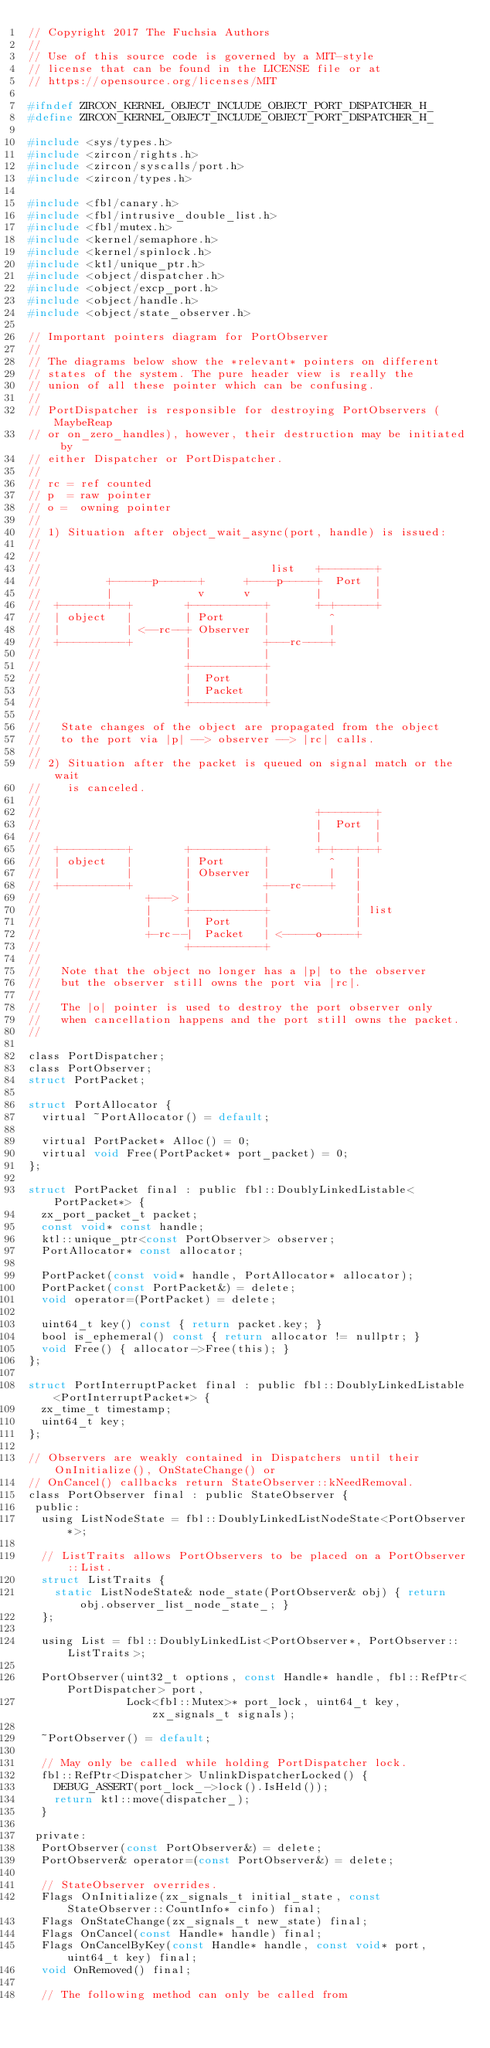Convert code to text. <code><loc_0><loc_0><loc_500><loc_500><_C_>// Copyright 2017 The Fuchsia Authors
//
// Use of this source code is governed by a MIT-style
// license that can be found in the LICENSE file or at
// https://opensource.org/licenses/MIT

#ifndef ZIRCON_KERNEL_OBJECT_INCLUDE_OBJECT_PORT_DISPATCHER_H_
#define ZIRCON_KERNEL_OBJECT_INCLUDE_OBJECT_PORT_DISPATCHER_H_

#include <sys/types.h>
#include <zircon/rights.h>
#include <zircon/syscalls/port.h>
#include <zircon/types.h>

#include <fbl/canary.h>
#include <fbl/intrusive_double_list.h>
#include <fbl/mutex.h>
#include <kernel/semaphore.h>
#include <kernel/spinlock.h>
#include <ktl/unique_ptr.h>
#include <object/dispatcher.h>
#include <object/excp_port.h>
#include <object/handle.h>
#include <object/state_observer.h>

// Important pointers diagram for PortObserver
//
// The diagrams below show the *relevant* pointers on different
// states of the system. The pure header view is really the
// union of all these pointer which can be confusing.
//
// PortDispatcher is responsible for destroying PortObservers (MaybeReap
// or on_zero_handles), however, their destruction may be initiated by
// either Dispatcher or PortDispatcher.
//
// rc = ref counted
// p  = raw pointer
// o =  owning pointer
//
// 1) Situation after object_wait_async(port, handle) is issued:
//
//
//                                   list   +--------+
//          +------p------+      +----p-----+  Port  |
//          |             v      v          |        |
//  +-------+--+        +-----------+       +-+------+
//  | object   |        | Port      |         ^
//  |          | <--rc--+ Observer  |         |
//  +----------+        |           +---rc----+
//                      |           |
//                      +-----------+
//                      |  Port     |
//                      |  Packet   |
//                      +-----------+
//
//   State changes of the object are propagated from the object
//   to the port via |p| --> observer --> |rc| calls.
//
// 2) Situation after the packet is queued on signal match or the wait
//    is canceled.
//
//                                          +--------+
//                                          |  Port  |
//                                          |        |
//  +----------+        +-----------+       +-+---+--+
//  | object   |        | Port      |         ^   |
//  |          |        | Observer  |         |   |
//  +----------+        |           +---rc----+   |
//                +---> |           |             |
//                |     +-----------+             | list
//                |     |  Port     |             |
//                +-rc--|  Packet   | <-----o-----+
//                      +-----------+
//
//   Note that the object no longer has a |p| to the observer
//   but the observer still owns the port via |rc|.
//
//   The |o| pointer is used to destroy the port observer only
//   when cancellation happens and the port still owns the packet.
//

class PortDispatcher;
class PortObserver;
struct PortPacket;

struct PortAllocator {
  virtual ~PortAllocator() = default;

  virtual PortPacket* Alloc() = 0;
  virtual void Free(PortPacket* port_packet) = 0;
};

struct PortPacket final : public fbl::DoublyLinkedListable<PortPacket*> {
  zx_port_packet_t packet;
  const void* const handle;
  ktl::unique_ptr<const PortObserver> observer;
  PortAllocator* const allocator;

  PortPacket(const void* handle, PortAllocator* allocator);
  PortPacket(const PortPacket&) = delete;
  void operator=(PortPacket) = delete;

  uint64_t key() const { return packet.key; }
  bool is_ephemeral() const { return allocator != nullptr; }
  void Free() { allocator->Free(this); }
};

struct PortInterruptPacket final : public fbl::DoublyLinkedListable<PortInterruptPacket*> {
  zx_time_t timestamp;
  uint64_t key;
};

// Observers are weakly contained in Dispatchers until their OnInitialize(), OnStateChange() or
// OnCancel() callbacks return StateObserver::kNeedRemoval.
class PortObserver final : public StateObserver {
 public:
  using ListNodeState = fbl::DoublyLinkedListNodeState<PortObserver*>;

  // ListTraits allows PortObservers to be placed on a PortObserver::List.
  struct ListTraits {
    static ListNodeState& node_state(PortObserver& obj) { return obj.observer_list_node_state_; }
  };

  using List = fbl::DoublyLinkedList<PortObserver*, PortObserver::ListTraits>;

  PortObserver(uint32_t options, const Handle* handle, fbl::RefPtr<PortDispatcher> port,
               Lock<fbl::Mutex>* port_lock, uint64_t key, zx_signals_t signals);

  ~PortObserver() = default;

  // May only be called while holding PortDispatcher lock.
  fbl::RefPtr<Dispatcher> UnlinkDispatcherLocked() {
    DEBUG_ASSERT(port_lock_->lock().IsHeld());
    return ktl::move(dispatcher_);
  }

 private:
  PortObserver(const PortObserver&) = delete;
  PortObserver& operator=(const PortObserver&) = delete;

  // StateObserver overrides.
  Flags OnInitialize(zx_signals_t initial_state, const StateObserver::CountInfo* cinfo) final;
  Flags OnStateChange(zx_signals_t new_state) final;
  Flags OnCancel(const Handle* handle) final;
  Flags OnCancelByKey(const Handle* handle, const void* port, uint64_t key) final;
  void OnRemoved() final;

  // The following method can only be called from</code> 